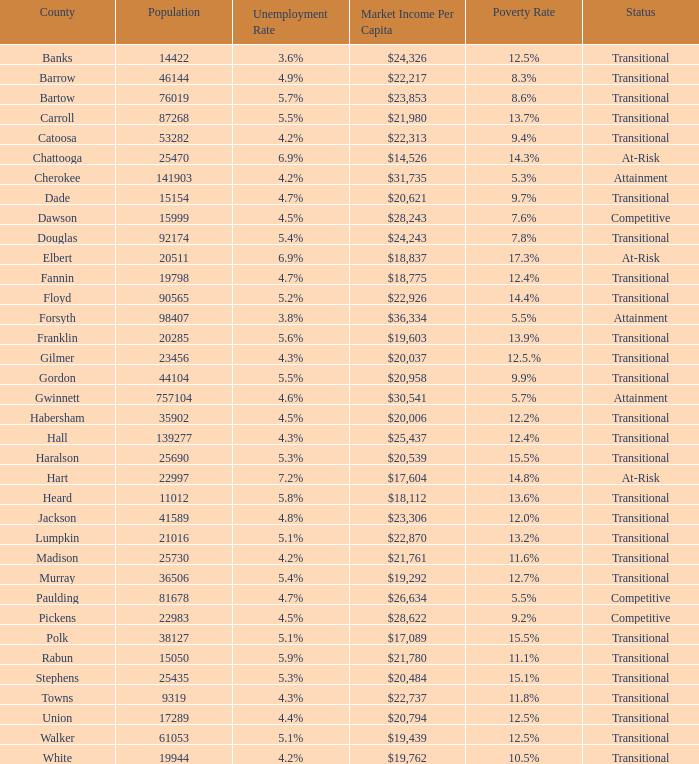What is the per capita market income for the county with a $22,313. 